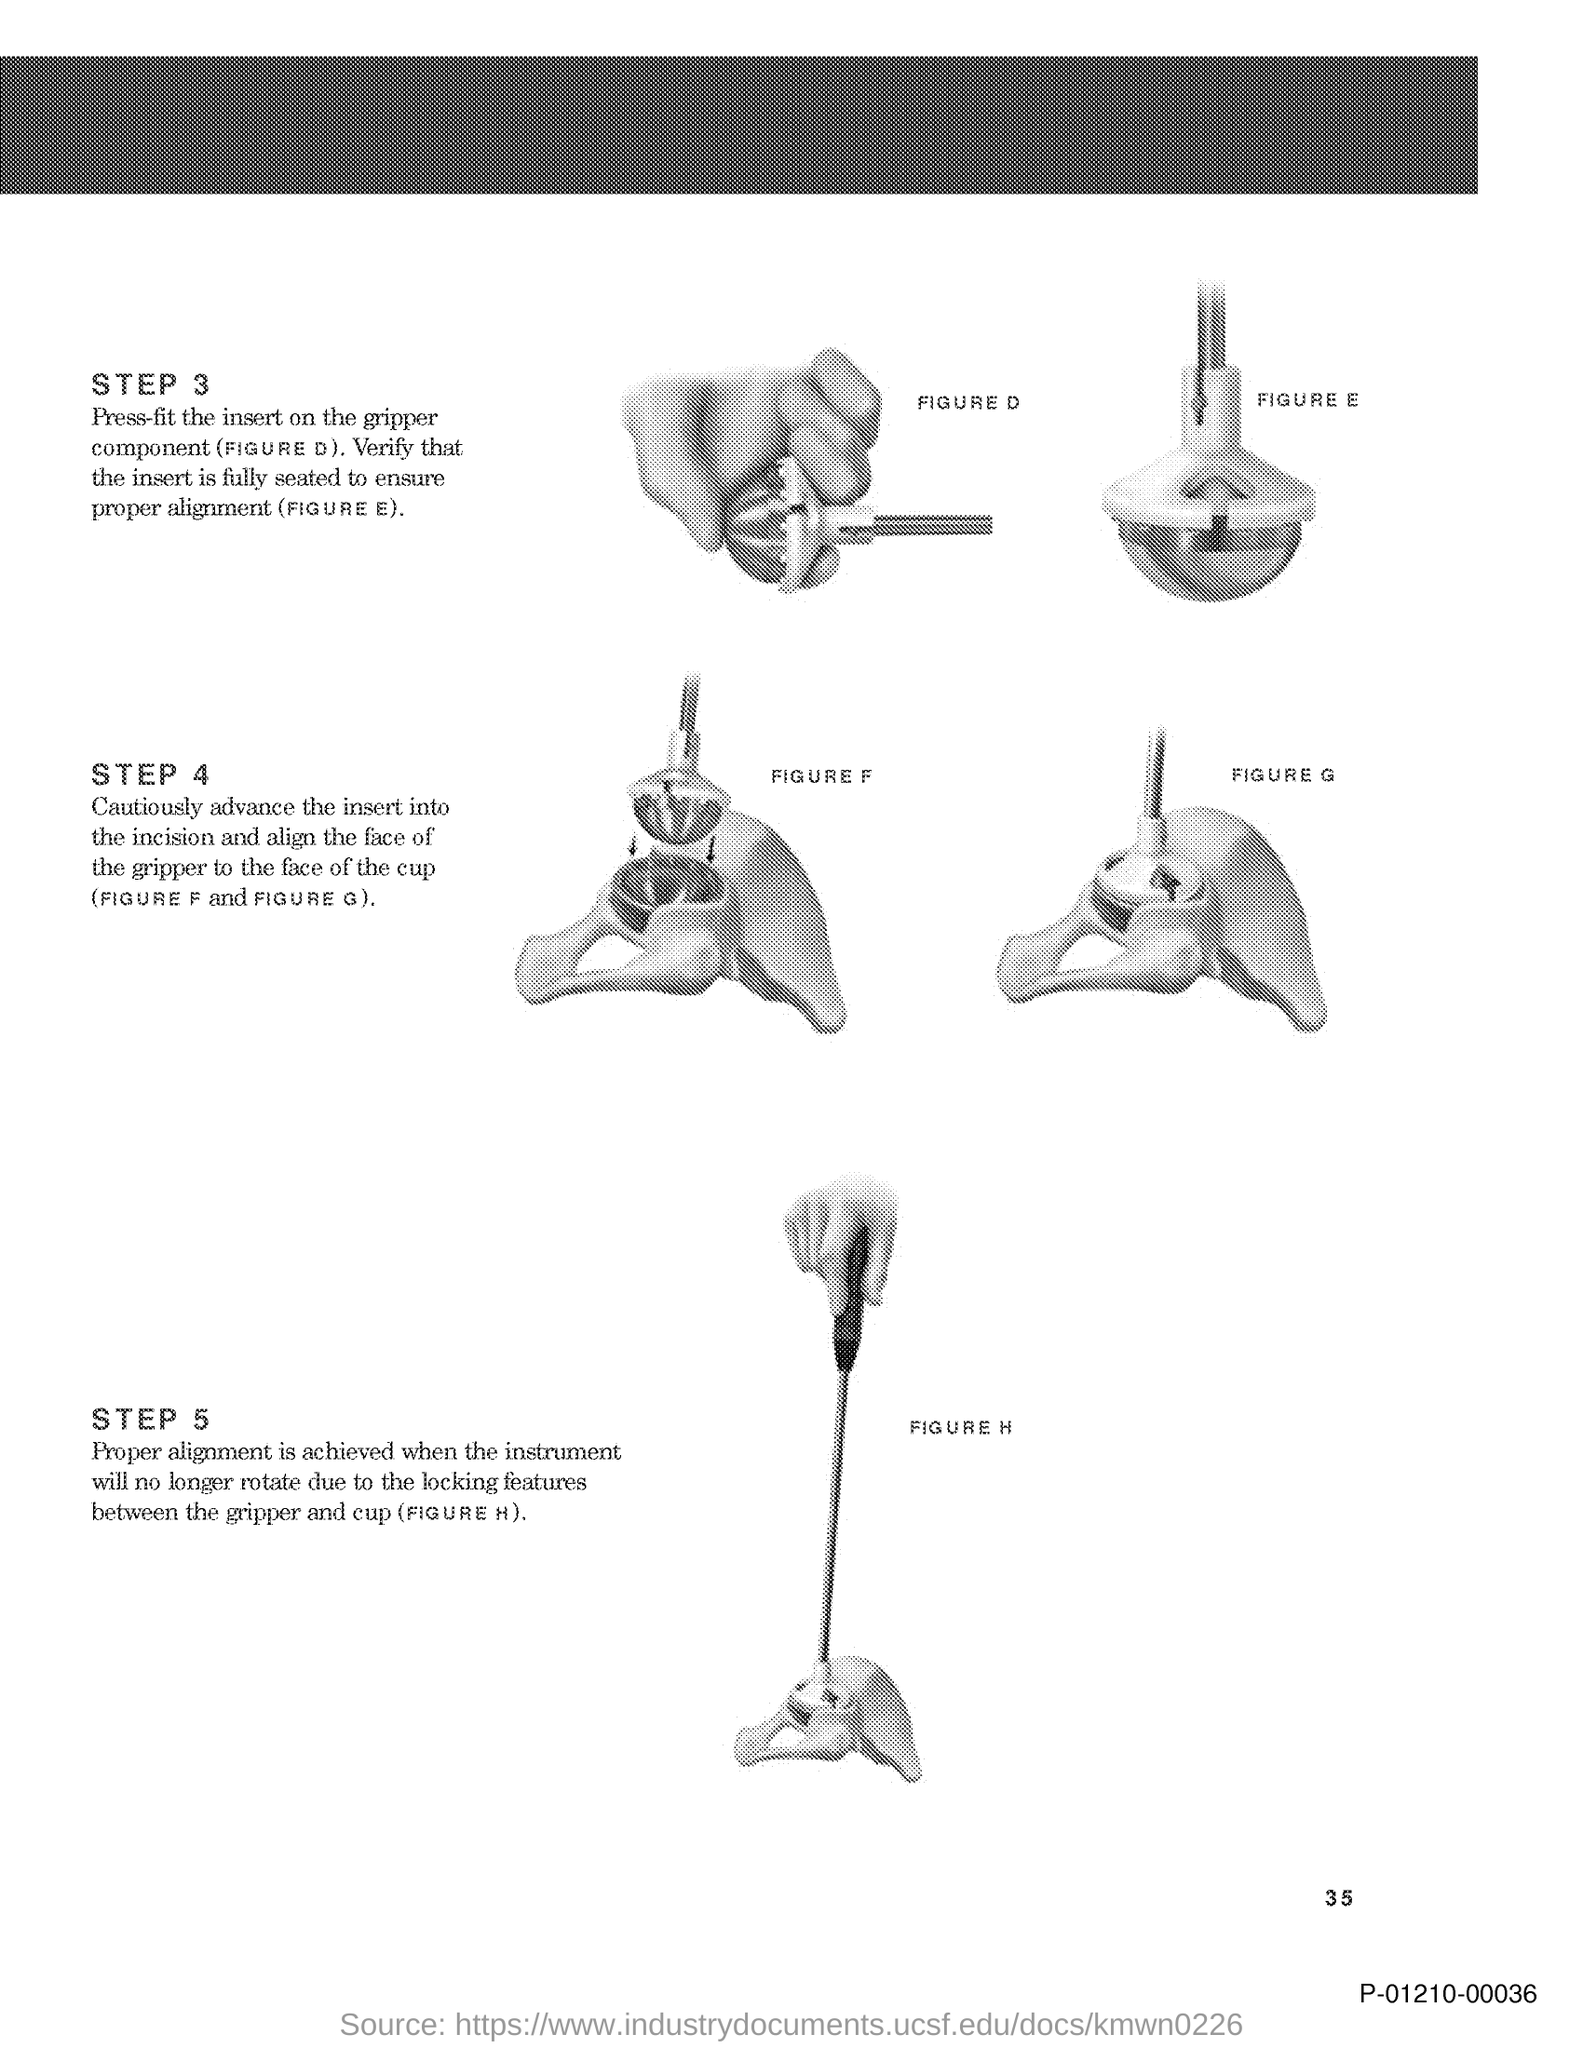Highlight a few significant elements in this photo. The figure D refers to the press-fit insert that is to be attached to the gripper component. The figure labeled 'FIGURE E' states, 'Verify that the insert is fully seated to ensure proper alignment.' The bottom right corner of the page displays a code consisting of P-01210-00036. The speaker is requesting information about the page number on a particular document. The speaker indicates that the page number is 35, but also provides the information in a roundabout manner by stating "on this document?" and using the word "what" to refer to the page number. 